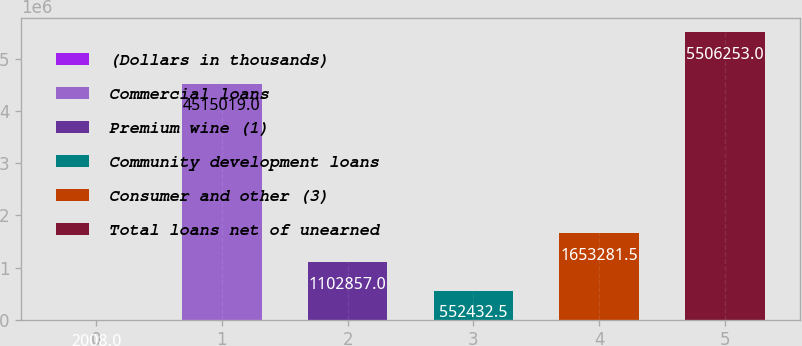<chart> <loc_0><loc_0><loc_500><loc_500><bar_chart><fcel>(Dollars in thousands)<fcel>Commercial loans<fcel>Premium wine (1)<fcel>Community development loans<fcel>Consumer and other (3)<fcel>Total loans net of unearned<nl><fcel>2008<fcel>4.51502e+06<fcel>1.10286e+06<fcel>552432<fcel>1.65328e+06<fcel>5.50625e+06<nl></chart> 